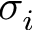<formula> <loc_0><loc_0><loc_500><loc_500>\sigma _ { i }</formula> 